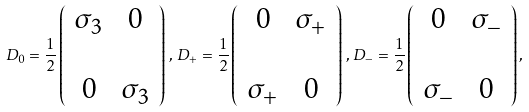<formula> <loc_0><loc_0><loc_500><loc_500>D _ { 0 } = \frac { 1 } { 2 } \left ( \begin{array} { c c } \sigma _ { 3 } & 0 \\ \\ 0 & \sigma _ { 3 } \end{array} \right ) \, , \, D _ { + } = \frac { 1 } { 2 } \left ( \begin{array} { c c } 0 & \sigma _ { + } \\ \\ \sigma _ { + } & 0 \end{array} \right ) \, , \, D _ { - } = \frac { 1 } { 2 } \left ( \begin{array} { c c } 0 & \sigma _ { - } \\ \\ \sigma _ { - } & 0 \end{array} \right ) ,</formula> 